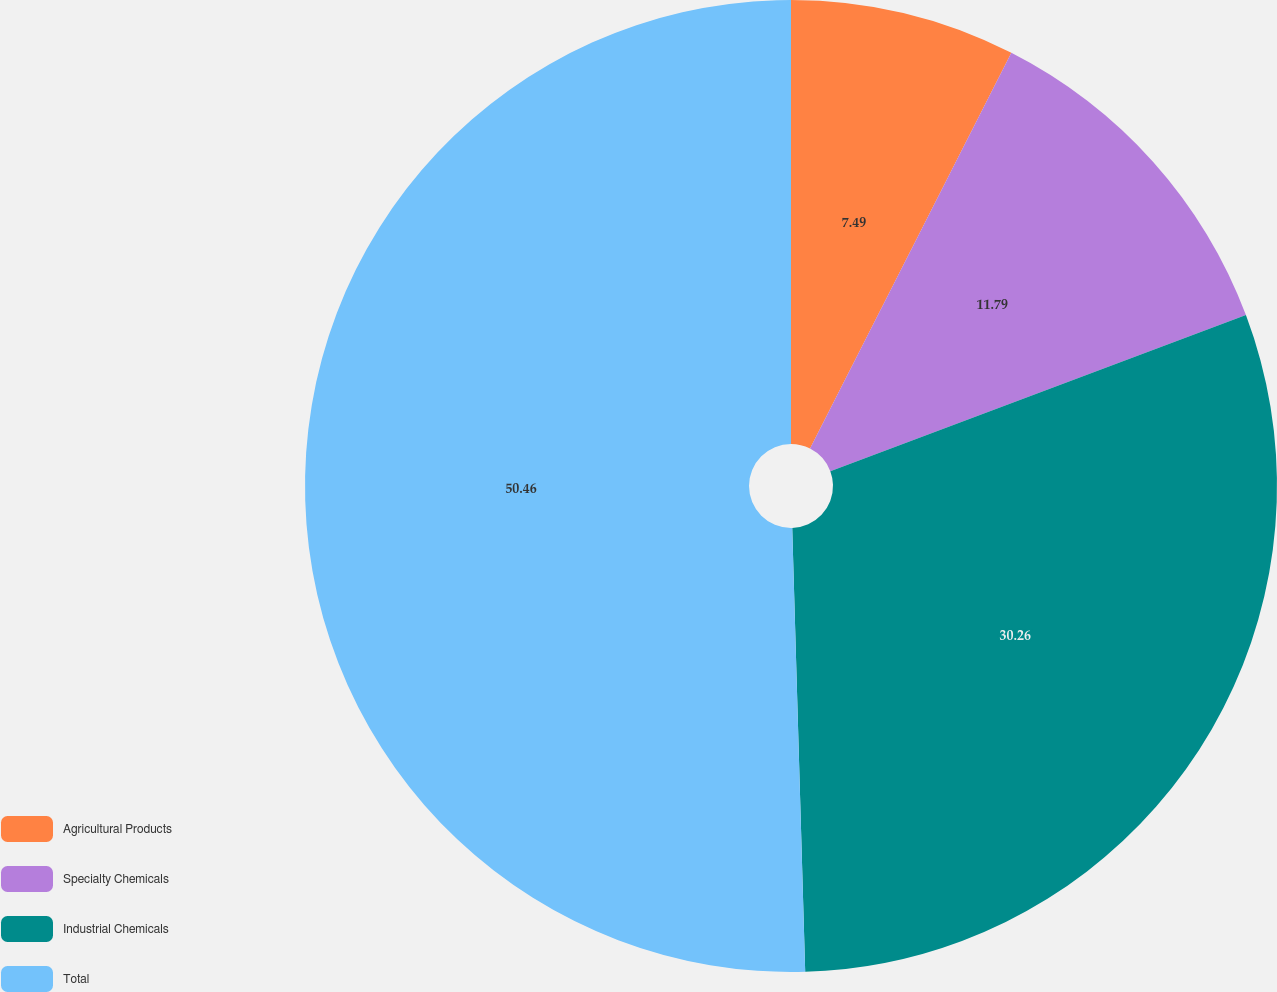Convert chart. <chart><loc_0><loc_0><loc_500><loc_500><pie_chart><fcel>Agricultural Products<fcel>Specialty Chemicals<fcel>Industrial Chemicals<fcel>Total<nl><fcel>7.49%<fcel>11.79%<fcel>30.26%<fcel>50.47%<nl></chart> 